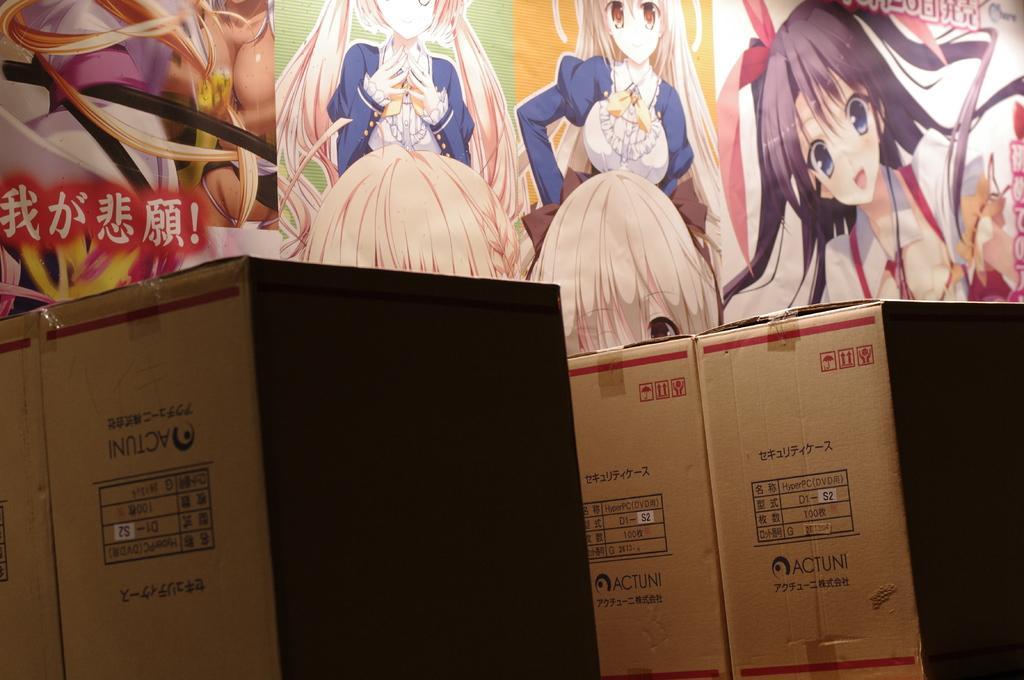Describe this image in one or two sentences. At the bottom of the image there are cardboard boxes. Behind the boxes there is a wall with paintings. 